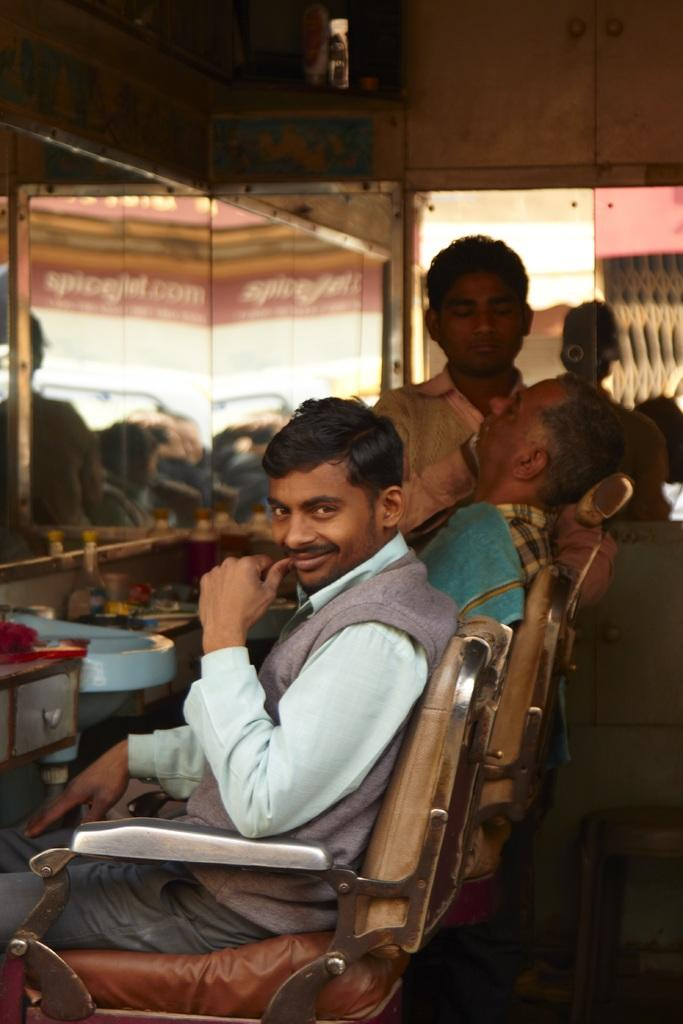What is the position of the person in the image? There is a person sitting on a chair, and another person standing on the top right side of the image. What is the facial expression of the person sitting on the chair? The person sitting on the chair is smiling. What is the standing person doing to the sitting person? The person standing is shaving the person sitting on the chair. How many groups of people can be seen in the image? There is only one group of people in the image, consisting of the person sitting on the chair and the person standing next to them. What type of mark is visible on the person sitting on the chair? There is no mention of any mark on the person sitting on the chair in the provided facts. 